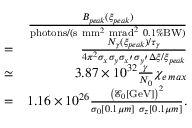<formula> <loc_0><loc_0><loc_500><loc_500>\begin{array} { r l r } & { \frac { B _ { p e a k } ( \xi _ { p e a k } ) } { p h o t o n s / ( s \ m m ^ { 2 } \ m r a d ^ { 2 } \ 0 . 1 \% B W ) } } \\ & { = } & { \frac { N _ { \gamma } ( \xi _ { p e a k } ) / \tau _ { \gamma } } { 4 \pi ^ { 2 } \sigma _ { x } \sigma _ { y } \sigma _ { x ^ { \prime } } \sigma _ { y ^ { \prime } } \Delta \xi / \xi _ { p e a k } } } \\ & { \simeq } & { 3 . 8 7 \times 1 0 ^ { 3 2 } \frac { \gamma } { N _ { 0 } } \chi _ { e \, \max } } \\ & { = } & { 1 . 1 6 \times 1 0 ^ { 2 6 } \frac { \left ( \mathcal { E } _ { 0 } [ G e V ] \right ) ^ { 2 } } { \sigma _ { 0 } [ 0 . 1 \mu m ] \ \sigma _ { z } [ 0 . 1 \mu m ] } . } \end{array}</formula> 